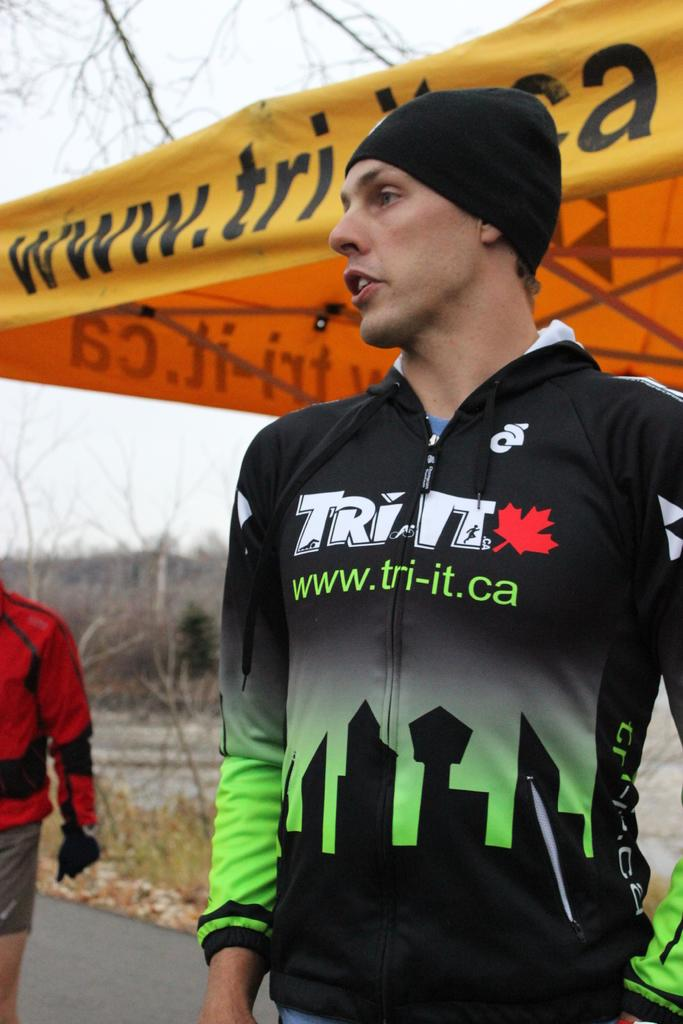<image>
Share a concise interpretation of the image provided. man wearing black and green zip up for tri it and yellow tent behind him with www.tri-it.ca on it 